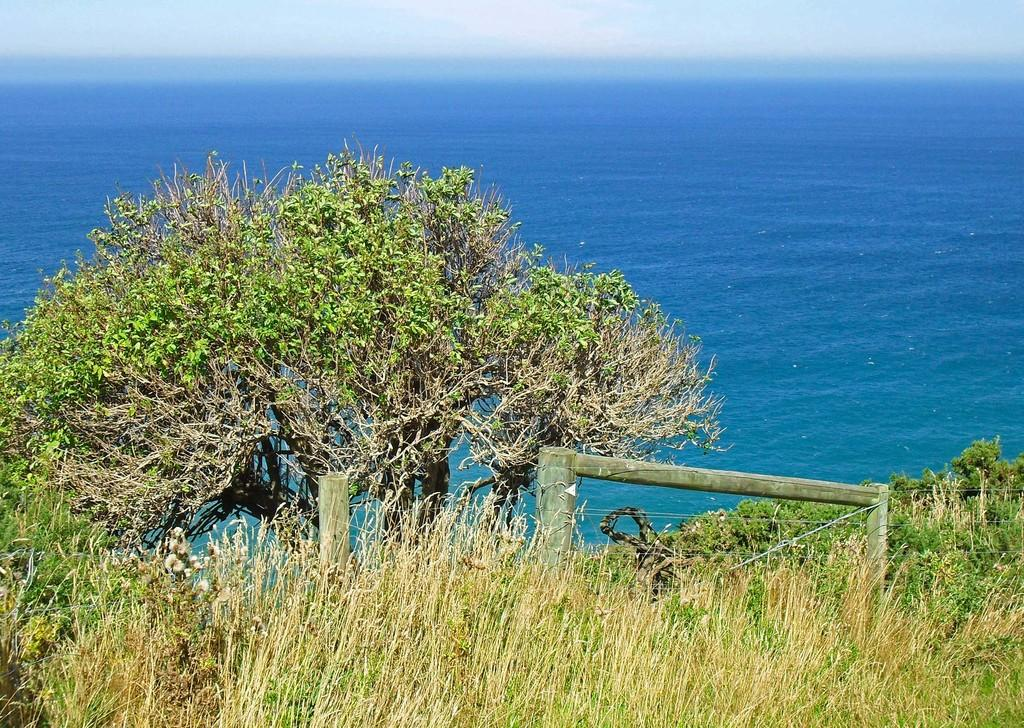What type of vegetation can be seen in the image? There is grass and trees in the image. What natural feature is visible in the background of the image? There is an ocean in the background of the image. What is the condition of the sky in the image? The sky is clear in the image. Where is the drawer located in the image? There is no drawer present in the image. How many cherries are hanging from the trees in the image? There are no cherries visible in the image; only grass and trees are present. 